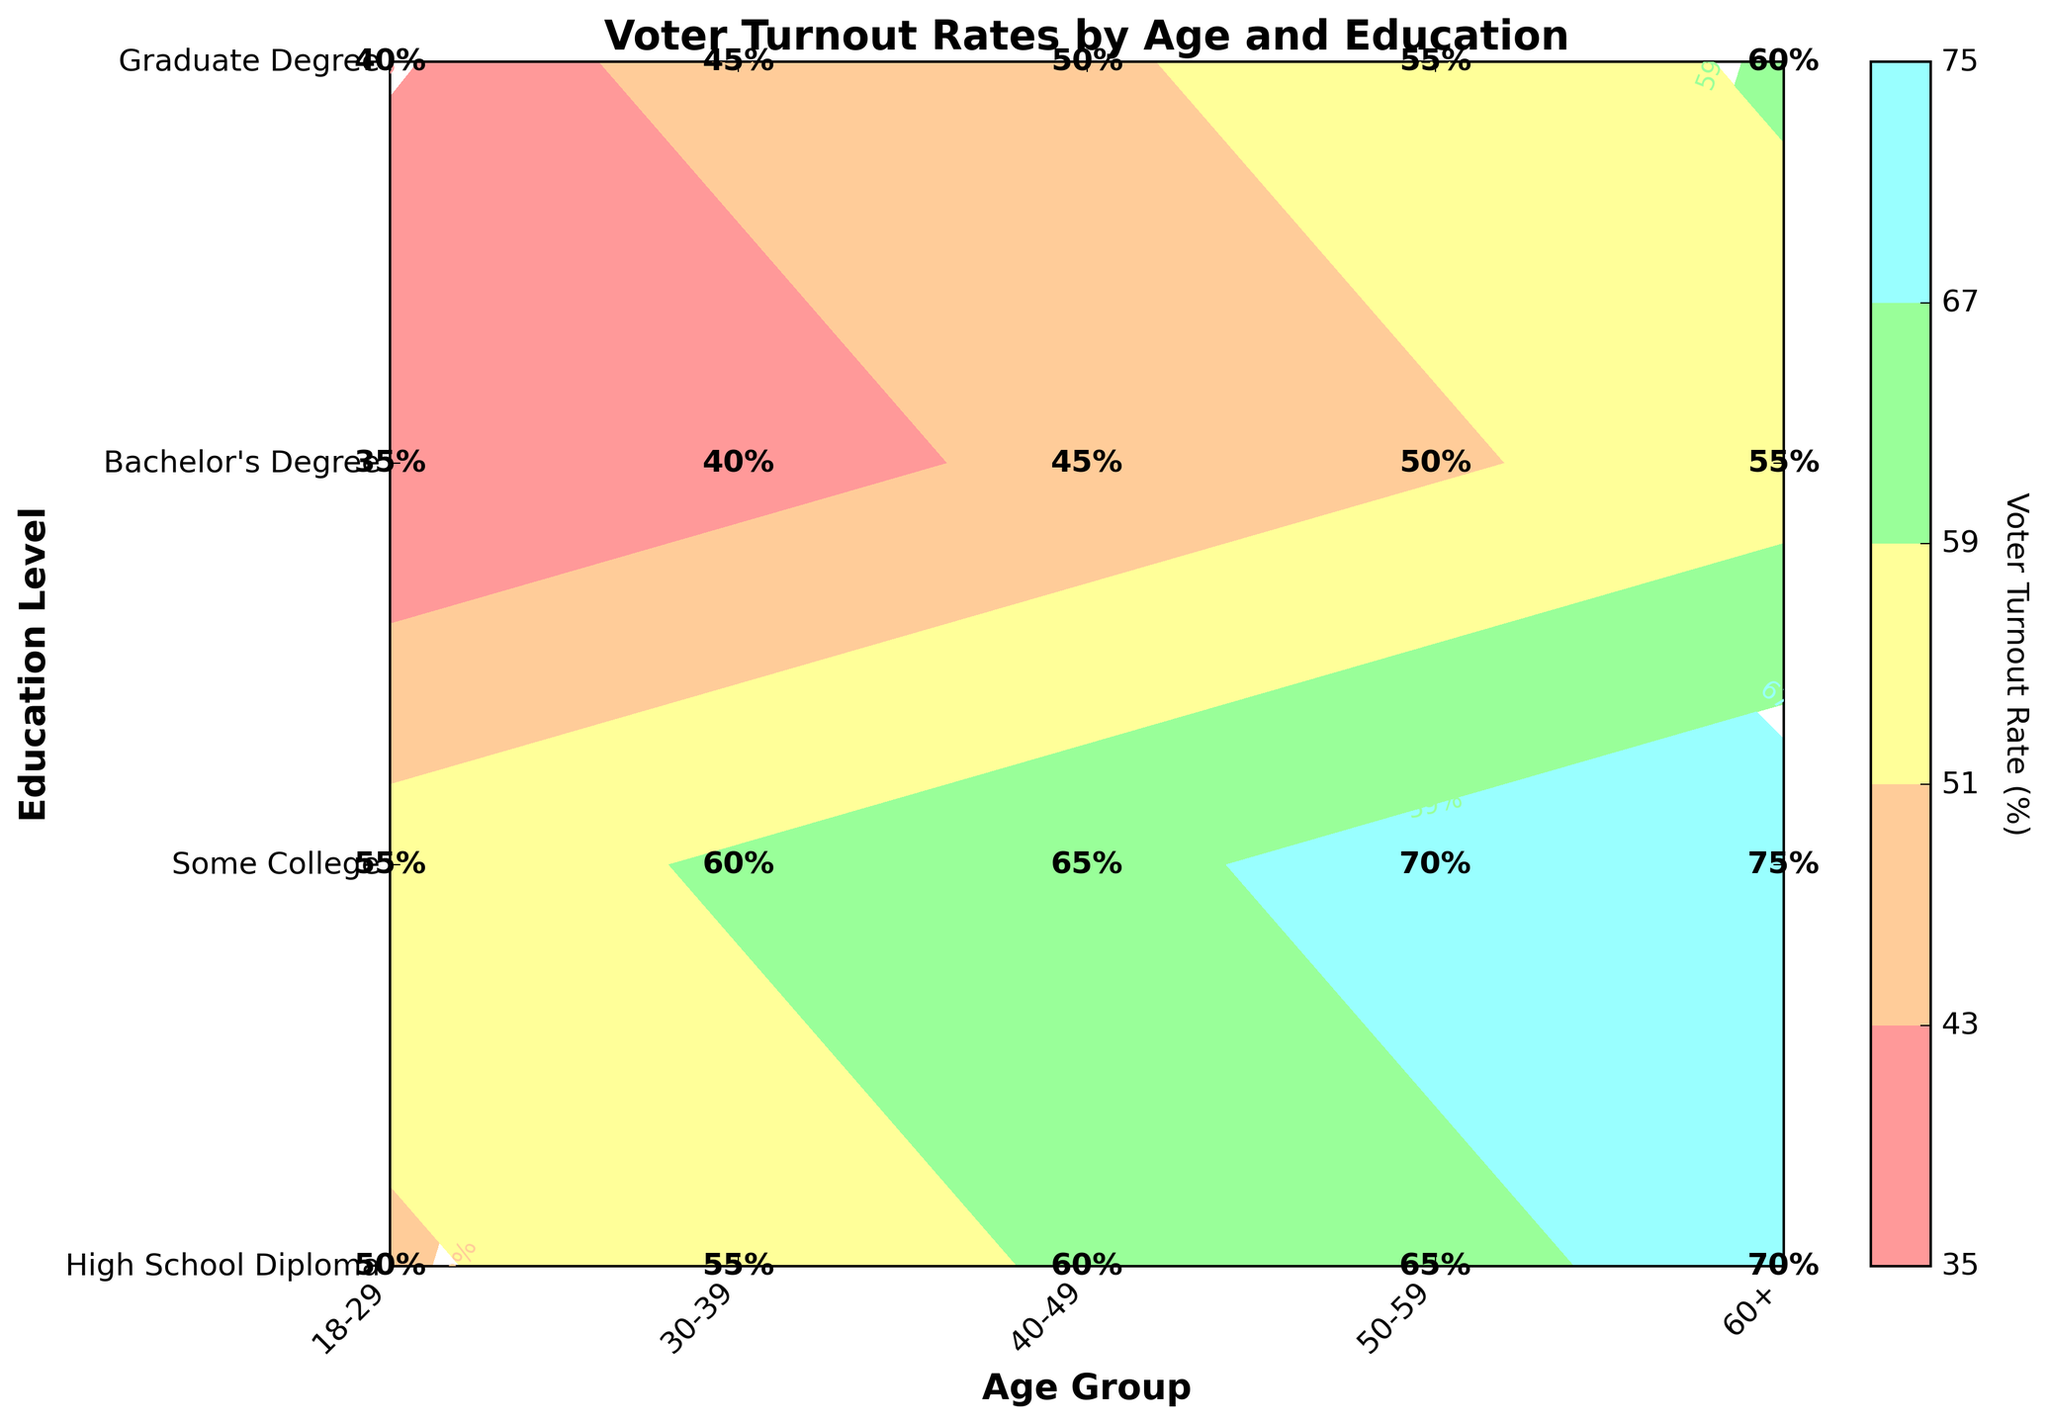What is the title of the plot? The title of the plot is displayed at the top of the figure and provides an overview of what the plot represents.
Answer: Voter Turnout Rates by Age and Education What is the voter turnout rate for individuals aged 30-39 with a Bachelor's Degree? To find the voter turnout rate, locate the intersection of the "30-39" age group and "Bachelor's Degree" education level.
Answer: 55% Which age group has the highest voter turnout rate for individuals with only a High School Diploma? Look for the highest value along the "High School Diploma" row.
Answer: 60+ What is the difference in voter turnout rates between individuals aged 18-29 with a Graduate Degree and those aged 18-29 with a High School Diploma? Subtract the turnout rate for High School Diploma from that for Graduate Degree within the "18-29" age group. (55% - 35%)
Answer: 20% Among individuals with a Bachelor's Degree, which age group has the lowest voter turnout rate? Look for the smallest value along the "Bachelor's Degree" row.
Answer: 18-29 What is the average voter turnout rate for the 50-59 age group across all education levels? Sum the voter turnout rates for "50-59" age group and divide by the number of education levels. (50 + 55 + 65 + 70) / 4
Answer: 60% Are there any age groups where the voter turnout rate increases consistently with higher education levels? Examine each age group to see if the voter turnout rate increases as education level increases.
Answer: Yes, all age groups show this consistent increase What is the voter turnout rate for the 40-49 age group with Some College education? Identify the intersection of "40-49" age group and "Some College" education level.
Answer: 50% In which age group does the Graduate Degree group have the highest voter turnout rate? Find the highest value in the "Graduate Degree" row and note the corresponding age group.
Answer: 60+ How do the voter turnout rates for individuals aged 60+ compare between those with a High School Diploma and those with Some College education? Compare the values for "High School Diploma" and "Some College" within the "60+" age group.
Answer: High School Diploma: 55%, Some College: 60% 